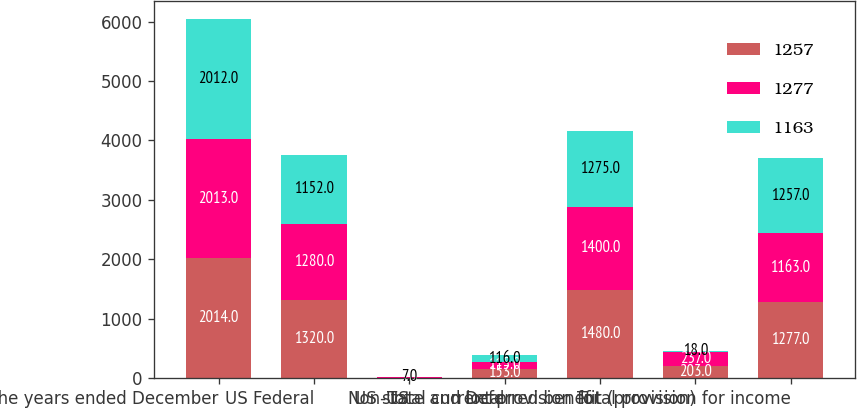Convert chart. <chart><loc_0><loc_0><loc_500><loc_500><stacked_bar_chart><ecel><fcel>For the years ended December<fcel>US Federal<fcel>Non-US<fcel>US state and local<fcel>Total current provision for<fcel>Deferred benefit (provision)<fcel>Total provision for income<nl><fcel>1257<fcel>2014<fcel>1320<fcel>7<fcel>153<fcel>1480<fcel>203<fcel>1277<nl><fcel>1277<fcel>2013<fcel>1280<fcel>5<fcel>115<fcel>1400<fcel>237<fcel>1163<nl><fcel>1163<fcel>2012<fcel>1152<fcel>7<fcel>116<fcel>1275<fcel>18<fcel>1257<nl></chart> 